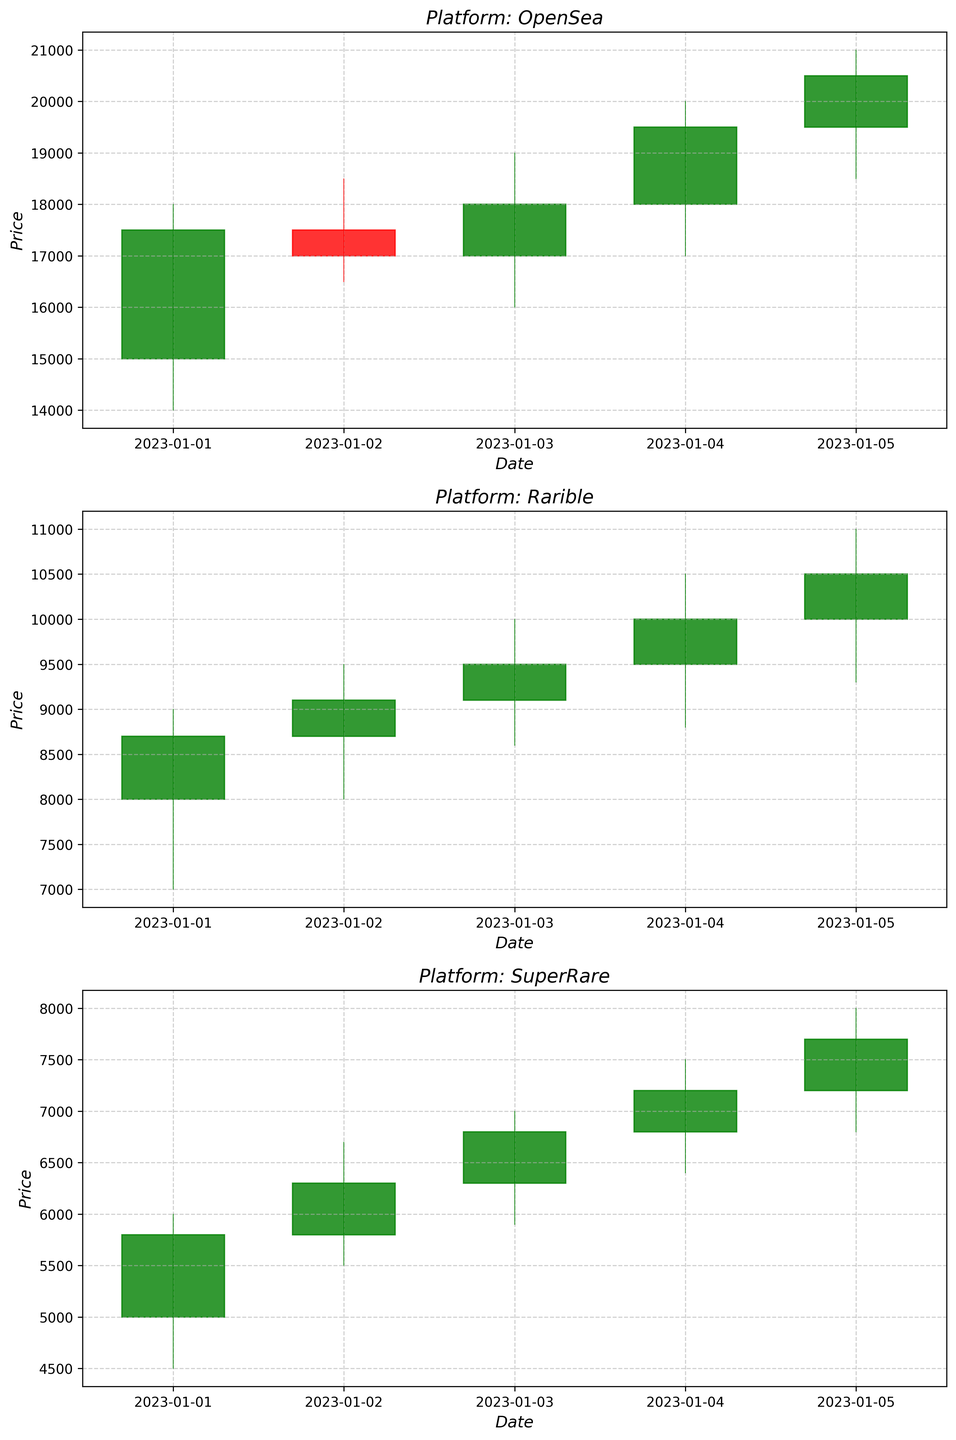What's the highest closing price on Rarible? To find the highest closing price on Rarible, we look at the candlestick chart for the Rarible platform and observe the closing prices over the days. The highest closing price is reached on the last day displayed.
Answer: 10500 Between OpenSea and SuperRare, which platform had a higher average volume over the dates? To calculate the average volume for each platform, we sum the volumes for the dates and divide by the number of days. OpenSea's volume is (1200 + 1100 + 1050 + 1300 + 1400) / 5 = 1210. SuperRare's volume is (400 + 450 + 500 + 550 + 600) / 5 = 500. OpenSea's average volume is higher.
Answer: OpenSea Which platform showed the most significant price increase between January 1st and January 5th? We compare the closing prices on January 1st and January 5th for all platforms. OpenSea: 17500 to 20500, Rarible: 8700 to 10500, SuperRare: 5800 to 7700. Calculate the difference for each platform (OpenSea: 3000, Rarible: 1800, SuperRare: 1900). OpenSea had the most significant increase.
Answer: OpenSea What visual difference can be observed in candlestick colors for OpenSea between January 1st and January 5th? Candlestick colors indicate the price movement; green for an increase from open to close, and red for a decrease. For OpenSea, observe the series of candlestick colors between January 1st and January 5th. The progression would be mixed, showing both green and a potential red candlestick, indicating varied price changes.
Answer: Mixed colors How did the closing prices trend for SuperRare from January 1st to January 5th? To determine the trend, examine the closing prices for each day on the SuperRare chart. SuperRare's closing prices are 5800, 6300, 6800, 7200, and 7700, showing a consistent upward trend.
Answer: Upward trend On which day did OpenSea have the highest trading volume? To find this, we look at the volume bars for OpenSea on the candlestick chart and identify the highest bar.
Answer: January 5th Which platform had the smallest range in price on January 3rd? We calculate the range (High - Low) for January 3rd for each platform. OpenSea: 19000 - 16000 = 3000, Rarible: 10000 - 8600 = 1400, SuperRare: 7000 - 5900 = 1100. SuperRare has the smallest range.
Answer: SuperRare How many days did the closing price decrease on Rarible from one day to the next? We compare consecutive days' closing prices on the Rarible chart to count the days when the closing price dropped. The prices sequentially are 8700, 9100, 9500, 10000, 10500, showing no days of decrease.
Answer: 0 days Which platform had the most consistent daily increase in closing prices? To find the most consistent increase, check the consecutive daily closing prices for each platform. The platform with a successive increase with no decrease is identified. Rarible and SuperRare both show consistent increases, so both could be the answer.
Answer: Rarible & SuperRare 